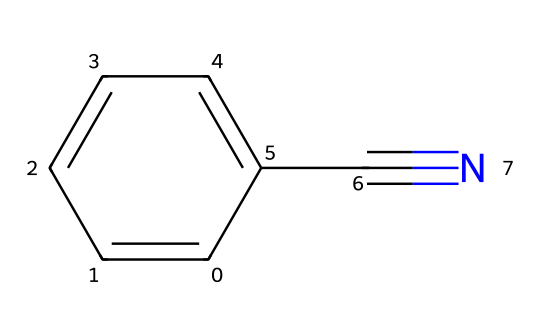What is the name of this chemical? The SMILES notation c1ccccc1C#N indicates that this compound has a benzonitrile structure, where a benzene ring is attached to a nitrile group (C#N).
Answer: benzonitrile How many carbon atoms are present in this structure? The structure consists of a benzene ring (which has 6 carbon atoms) plus one carbon atom from the nitrile group, totaling 7 carbon atoms.
Answer: 7 How many double bonds are in this chemical structure? The benzene ring contains 3 double bonds (as it is an aromatic structure), and there are no additional double bonds in the nitrile group.
Answer: 3 What functional group is indicated by the C#N part? The C#N notation represents a nitrile functional group, which is characterized by a carbon triple-bonded to a nitrogen atom.
Answer: nitrile Is this compound polar or nonpolar? The presence of the electronegative nitrogen atom in the nitrile group contributes to the overall polarity of the molecule, as does the structure of the benzene ring.
Answer: polar How does the nitrile (C#N) group affect the chemical properties of benzonitrile? The nitrile group significantly influences the reactivity and properties of benzonitrile, including its ability to participate in nucleophilic reactions, and increases the solvent polarity.
Answer: increases reactivity 